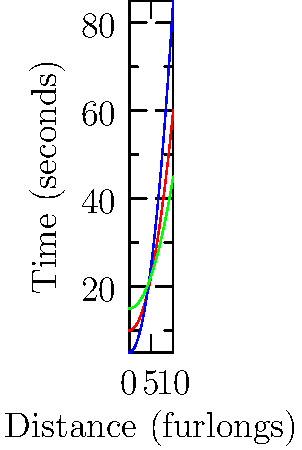Based on the performance graphs of three horses in a race, which horse would you consider the fastest over a 10-furlong distance? To determine the fastest horse over a 10-furlong distance, we need to analyze the performance graphs:

1. The x-axis represents the distance in furlongs, and the y-axis represents the time in seconds.
2. A faster horse will complete the race in less time, so we're looking for the graph with the lowest y-value at x = 10 furlongs.

3. Horse A (red line):
   At 10 furlongs, y ≈ 60 seconds

4. Horse B (blue line):
   At 10 furlongs, y ≈ 85 seconds

5. Horse C (green line):
   At 10 furlongs, y ≈ 45 seconds

6. Comparing the times at 10 furlongs:
   Horse C (45s) < Horse A (60s) < Horse B (85s)

Therefore, Horse C has the lowest time at 10 furlongs, making it the fastest horse over this distance.
Answer: Horse C 